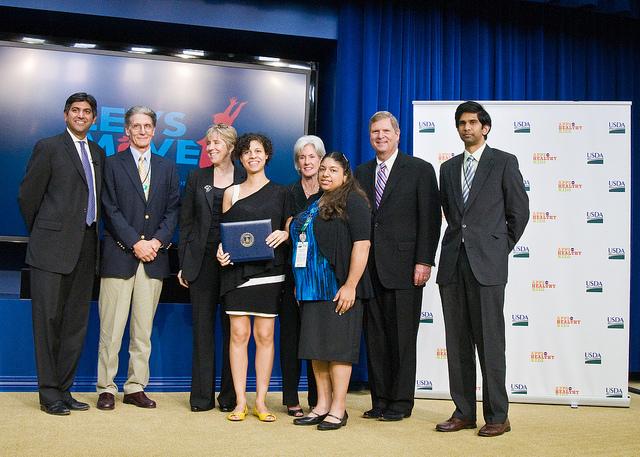Are the persons shown in a line?
Give a very brief answer. No. How many people have yellow shoes?
Concise answer only. 1. How many women are in the pic?
Answer briefly. 4. 